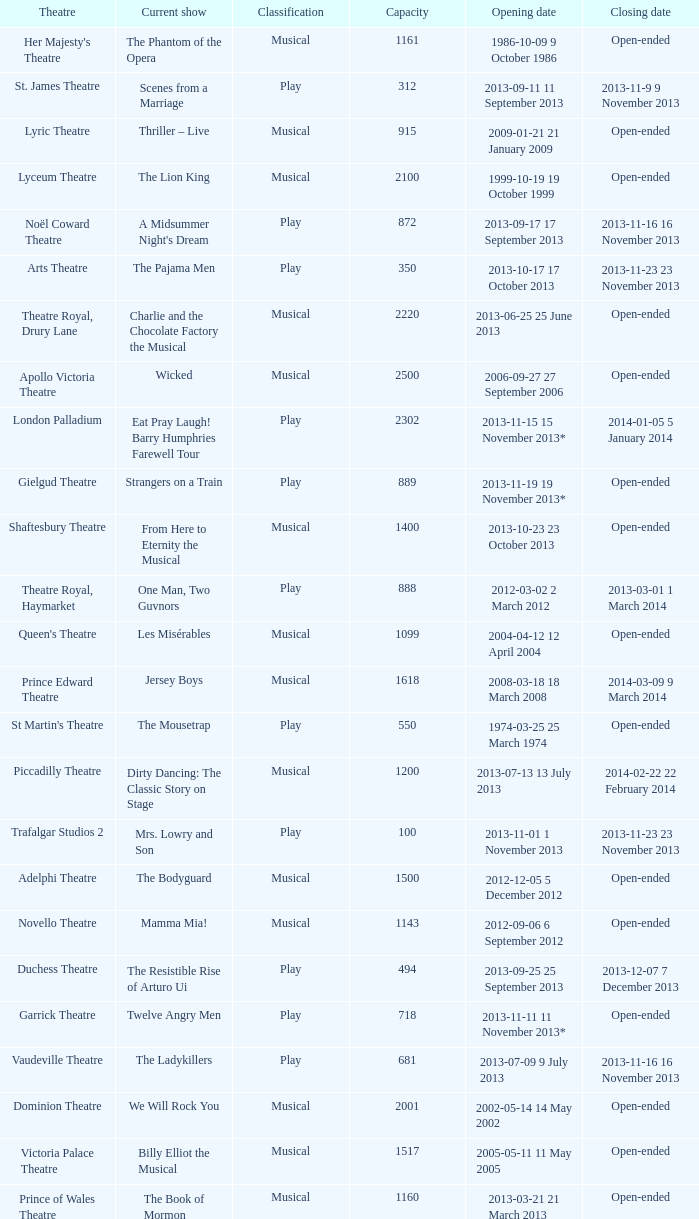What is the opening date of the musical at the adelphi theatre? 2012-12-05 5 December 2012. 